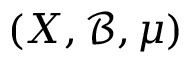Convert formula to latex. <formula><loc_0><loc_0><loc_500><loc_500>( X , { \mathcal { B } } , \mu )</formula> 